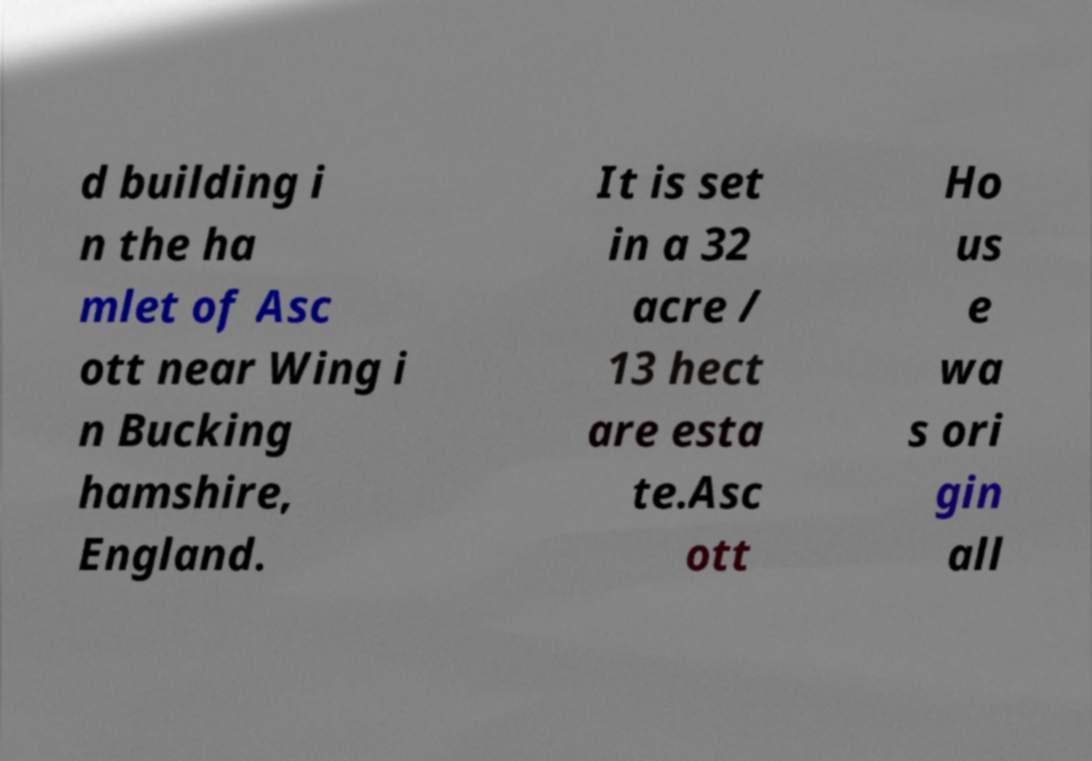Please read and relay the text visible in this image. What does it say? d building i n the ha mlet of Asc ott near Wing i n Bucking hamshire, England. It is set in a 32 acre / 13 hect are esta te.Asc ott Ho us e wa s ori gin all 